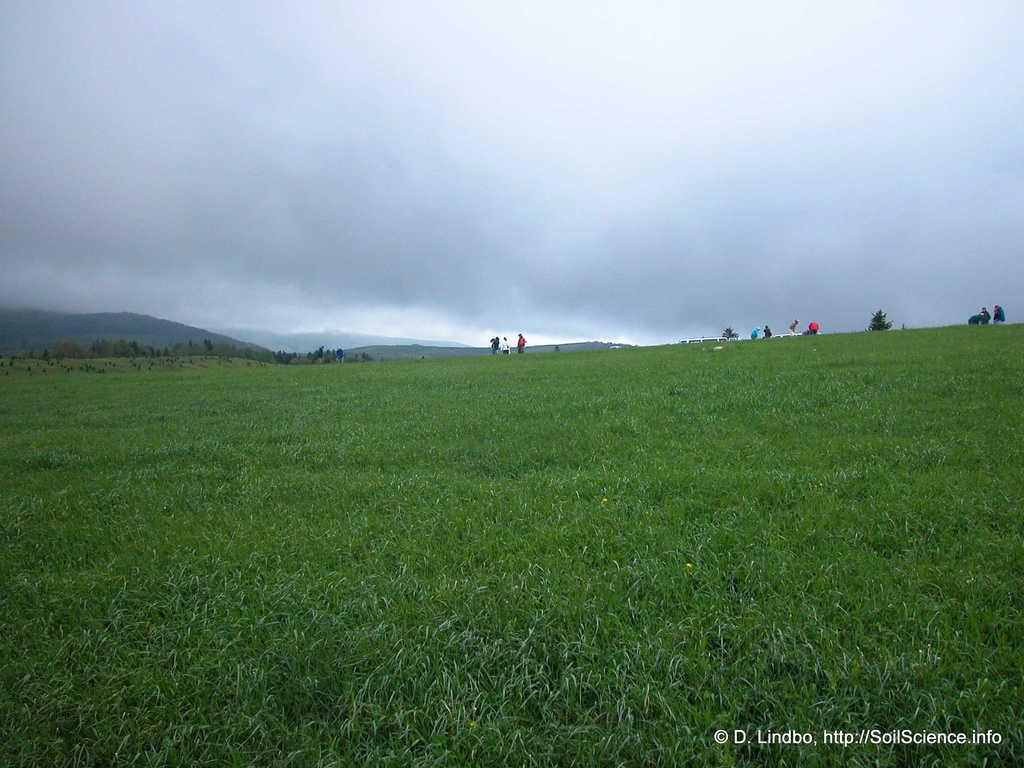Please provide a concise description of this image. At the bottom there is the grass, at the top it is the cloudy sky. 